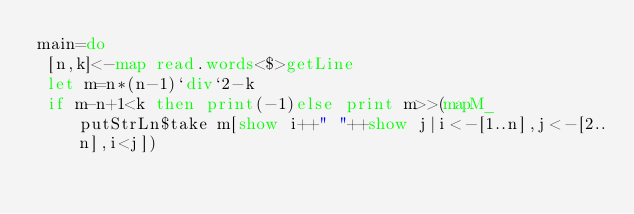Convert code to text. <code><loc_0><loc_0><loc_500><loc_500><_Haskell_>main=do
 [n,k]<-map read.words<$>getLine
 let m=n*(n-1)`div`2-k
 if m-n+1<k then print(-1)else print m>>(mapM_ putStrLn$take m[show i++" "++show j|i<-[1..n],j<-[2..n],i<j])</code> 